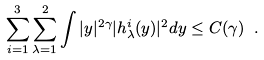Convert formula to latex. <formula><loc_0><loc_0><loc_500><loc_500>\sum _ { i = 1 } ^ { 3 } \sum _ { \lambda = 1 } ^ { 2 } \int | y | ^ { 2 \gamma } | h ^ { i } _ { \lambda } ( y ) | ^ { 2 } d y \leq C ( \gamma ) \ .</formula> 